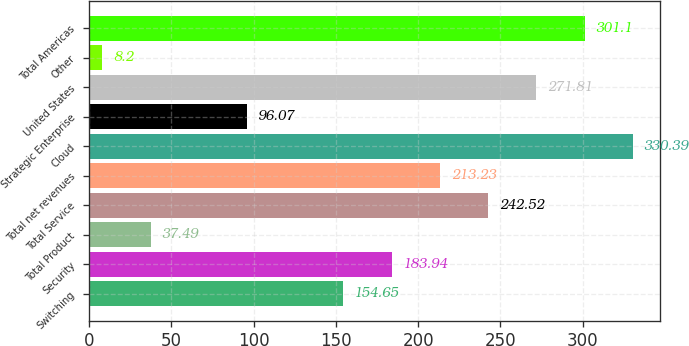Convert chart to OTSL. <chart><loc_0><loc_0><loc_500><loc_500><bar_chart><fcel>Switching<fcel>Security<fcel>Total Product<fcel>Total Service<fcel>Total net revenues<fcel>Cloud<fcel>Strategic Enterprise<fcel>United States<fcel>Other<fcel>Total Americas<nl><fcel>154.65<fcel>183.94<fcel>37.49<fcel>242.52<fcel>213.23<fcel>330.39<fcel>96.07<fcel>271.81<fcel>8.2<fcel>301.1<nl></chart> 